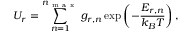<formula> <loc_0><loc_0><loc_500><loc_500>U _ { r } = \sum _ { n = 1 } ^ { n _ { m a x } } g _ { r , n } \exp \left ( - \frac { E _ { r , n } } { k _ { B } T } \right ) ,</formula> 